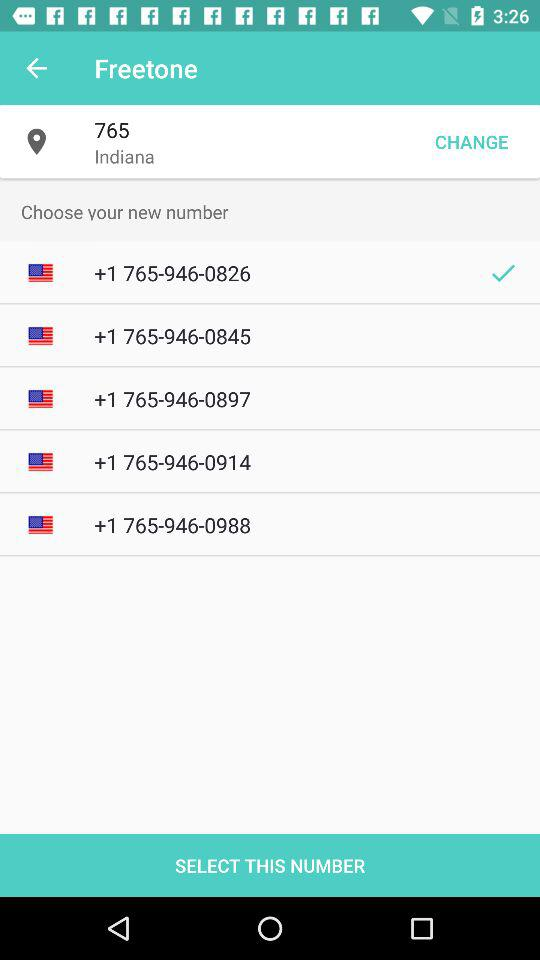Which new number is selected? The selected new number is +1 765-946-0826. 